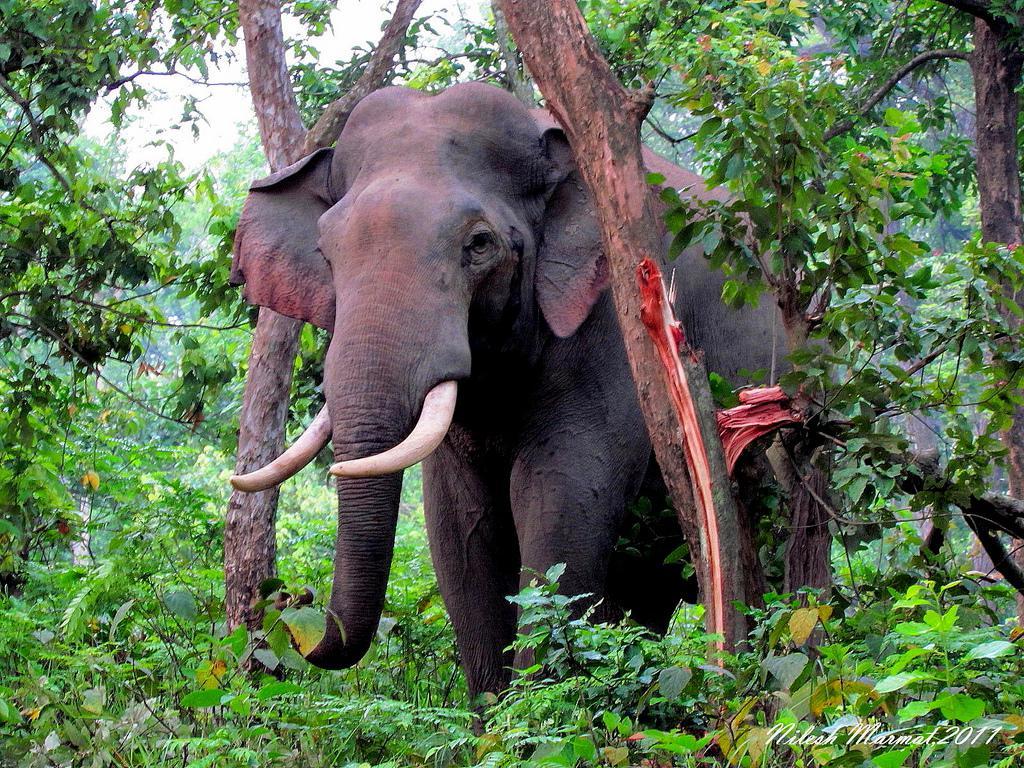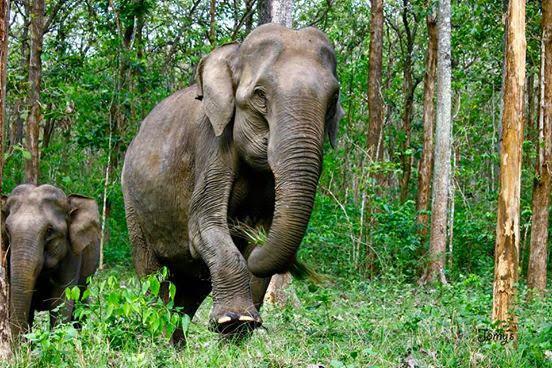The first image is the image on the left, the second image is the image on the right. For the images displayed, is the sentence "There are two animals in the grassy area in the image on the right." factually correct? Answer yes or no. Yes. 